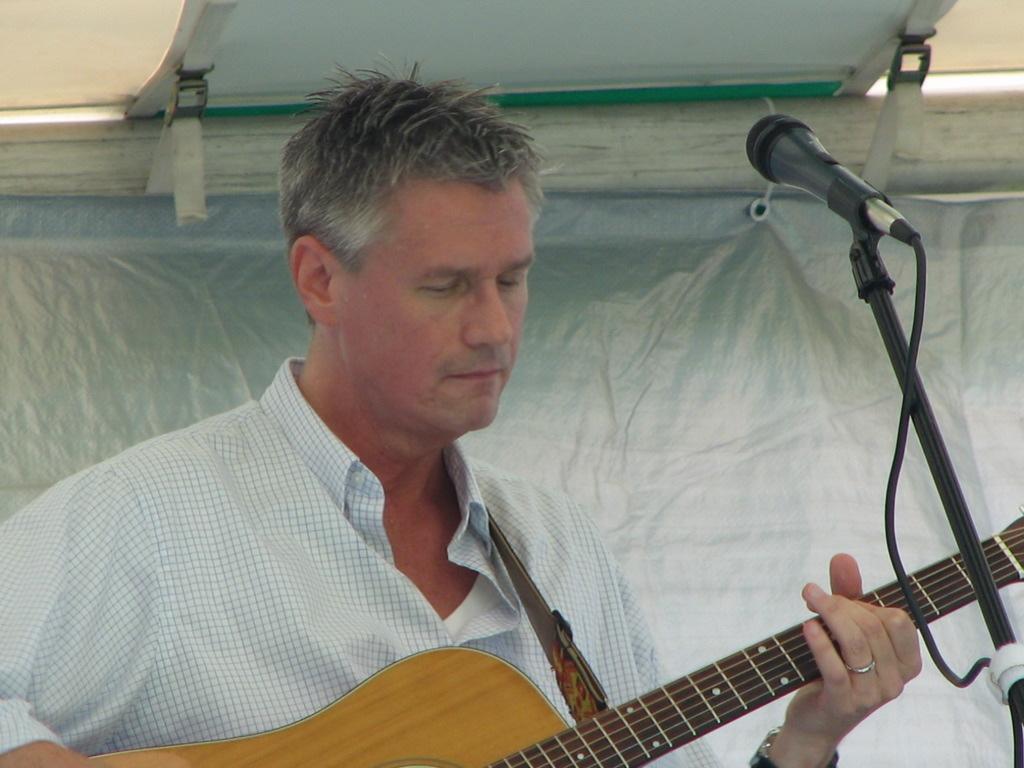Please provide a concise description of this image. In this image, there is a person standing and playing guitar in front of the mike. In the background, there is a curtain of white in color. It looks as if the image is taken outside the building during day time. 